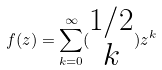<formula> <loc_0><loc_0><loc_500><loc_500>f ( z ) = \sum _ { k = 0 } ^ { \infty } ( \begin{matrix} 1 / 2 \\ k \end{matrix} ) z ^ { k }</formula> 